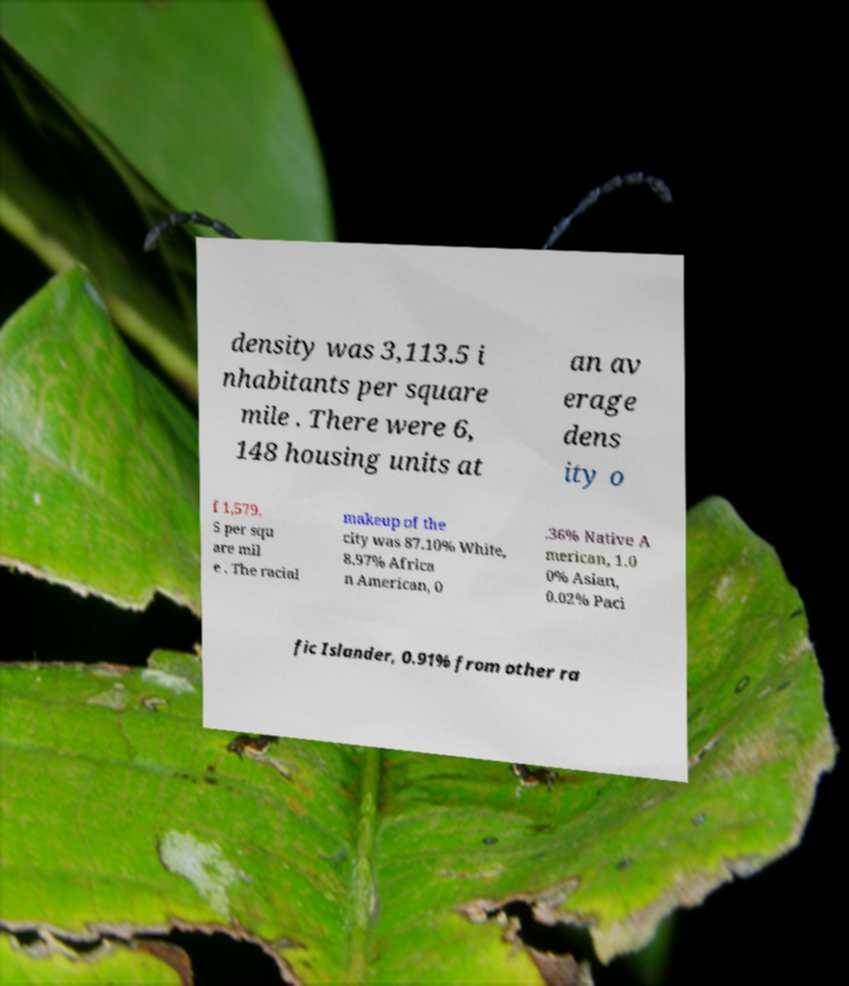Can you read and provide the text displayed in the image?This photo seems to have some interesting text. Can you extract and type it out for me? density was 3,113.5 i nhabitants per square mile . There were 6, 148 housing units at an av erage dens ity o f 1,579. 5 per squ are mil e . The racial makeup of the city was 87.10% White, 8.97% Africa n American, 0 .36% Native A merican, 1.0 0% Asian, 0.02% Paci fic Islander, 0.91% from other ra 